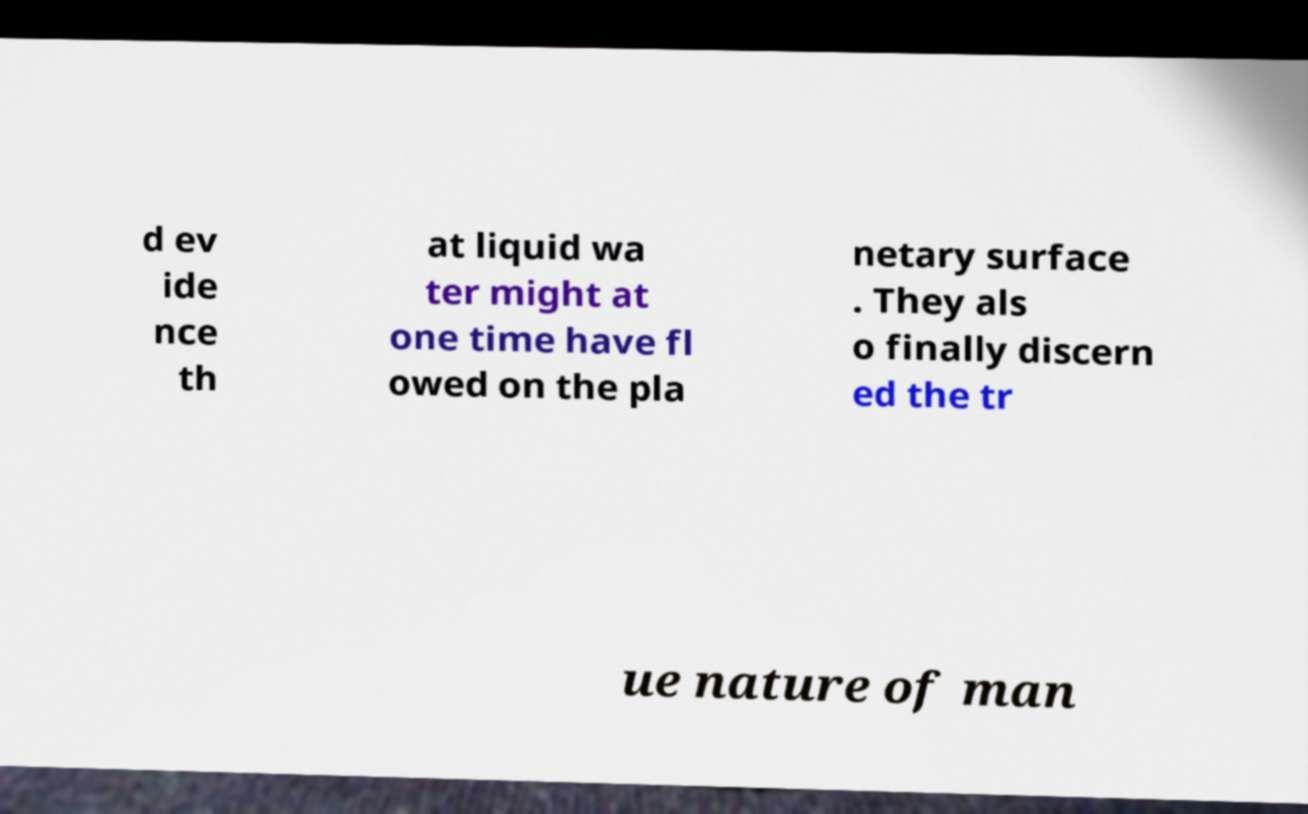There's text embedded in this image that I need extracted. Can you transcribe it verbatim? d ev ide nce th at liquid wa ter might at one time have fl owed on the pla netary surface . They als o finally discern ed the tr ue nature of man 